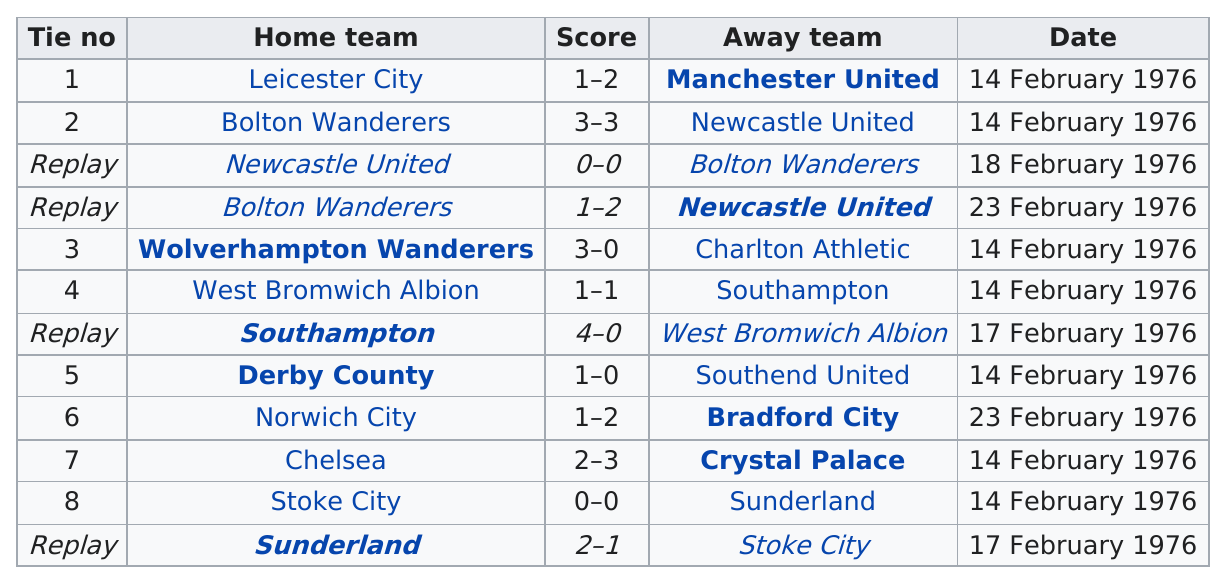Give some essential details in this illustration. Leicester City was the home team that won the game at the top of the table. Prior to the fifth round proper of a match between Bolton Wanderers and Newcastle United, the two teams played a total of three games with no clear winner. I am not certain what you are asking. Could you please clarify or provide more context? The difference between Southampton's score and Sunderland's score is two goals," declares. There are two games played by Sunderland that are listed here. 